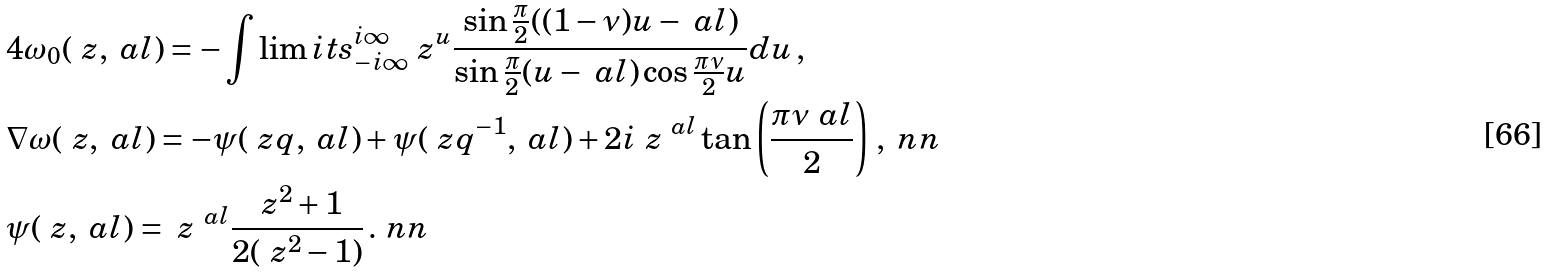Convert formula to latex. <formula><loc_0><loc_0><loc_500><loc_500>& 4 \omega _ { 0 } ( \ z , \ a l ) = - \int \lim i t s _ { - i \infty } ^ { i \infty } \ z ^ { u } \frac { \sin \frac { \pi } 2 ( ( 1 - \nu ) u - \ a l ) } { \sin \frac { \pi } 2 ( u - \ a l ) \cos \frac { \pi \nu } 2 u } d u \, , \\ & \nabla \omega ( \ z , \ a l ) = - \psi ( \ z q , \ a l ) + \psi ( \ z q ^ { - 1 } , \ a l ) + 2 i \ z ^ { \ a l } \tan \left ( \frac { \pi \nu \ a l } 2 \right ) \, , \ n n \\ & \psi ( \ z , \ a l ) = \ z ^ { \ a l } \frac { \ z ^ { 2 } + 1 } { 2 ( \ z ^ { 2 } - 1 ) } \, . \ n n</formula> 